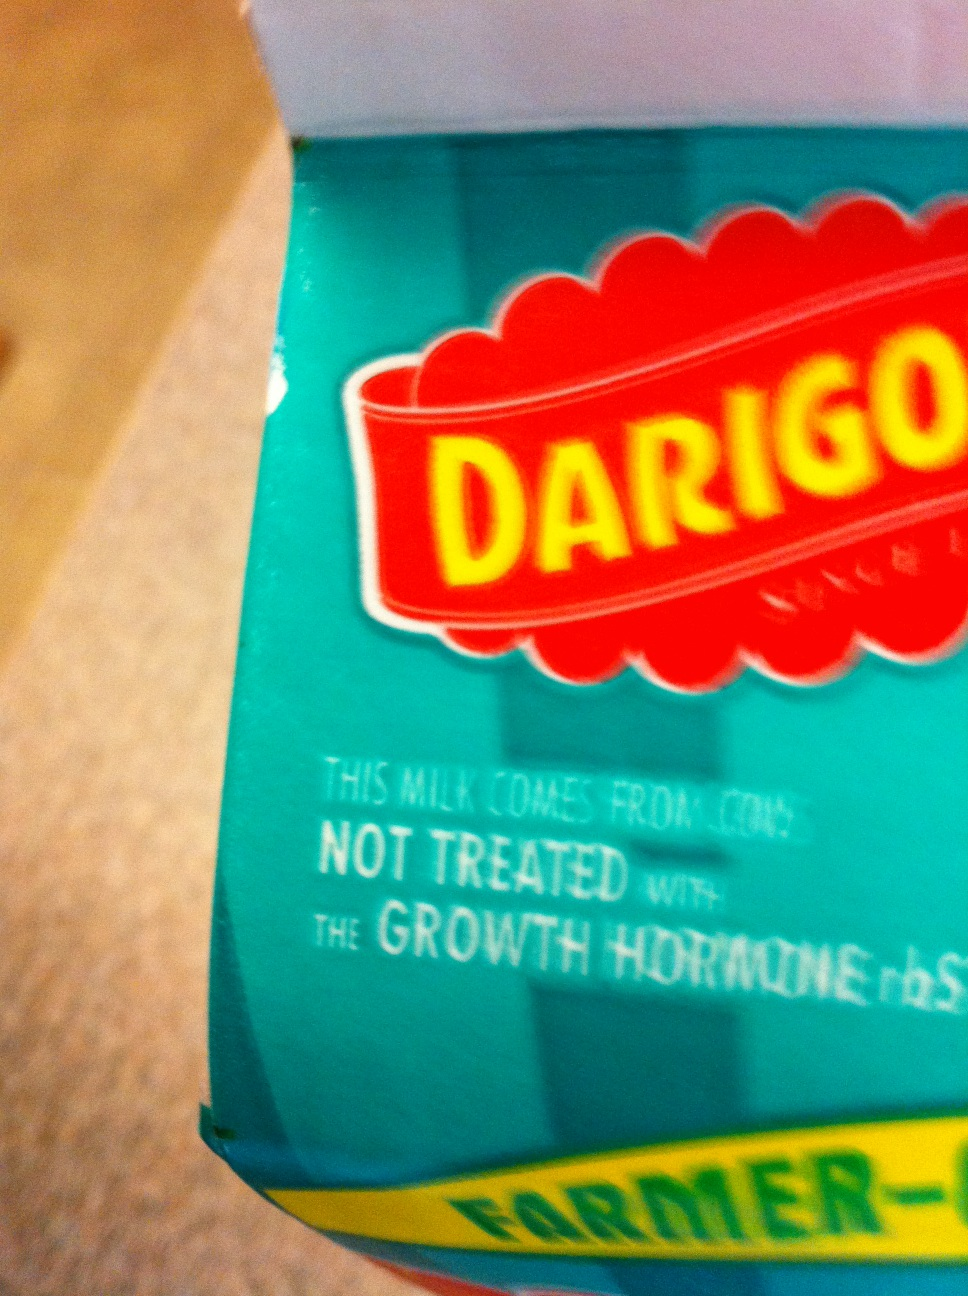Please provide guidance on how I can find the expiration date. Certainly! To find the expiration date on a milk carton, you typically want to check the top edge or the side facing outwards when placed on a shelf. The date is usually printed or stamped there in an easy-to-read format, often with the words 'best by', 'sell by', or 'use by' followed by the date. Make sure the area is well-lit and the camera is focused to capture a clear image of the text. 